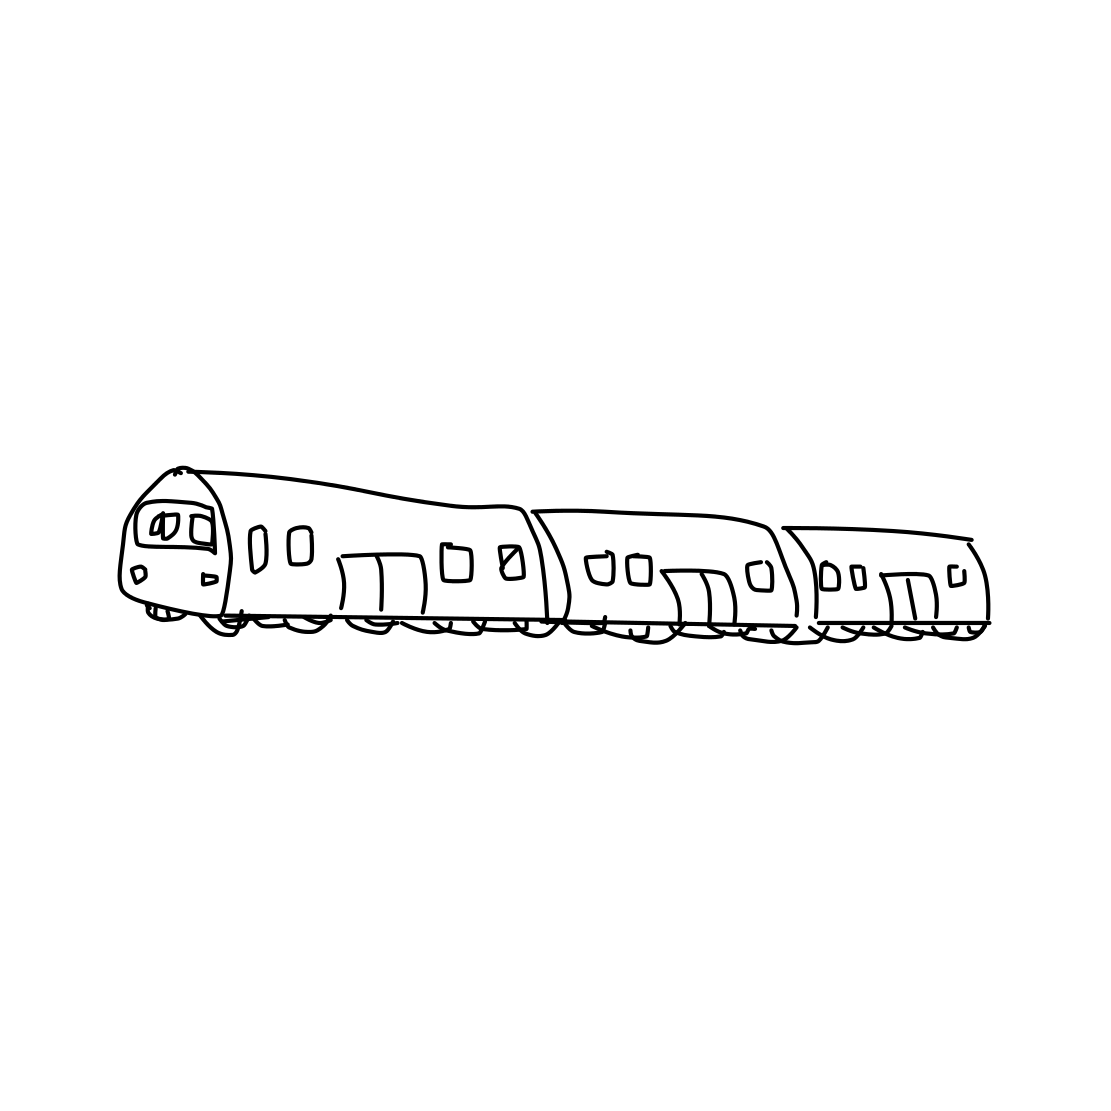Is there a sketchy sailboat in the picture? The image does not feature a sailboat. Instead, it depicts a sketch of a train, characterized by its elongated body, multiple windows, and wheels suggestive of railway transportation. 